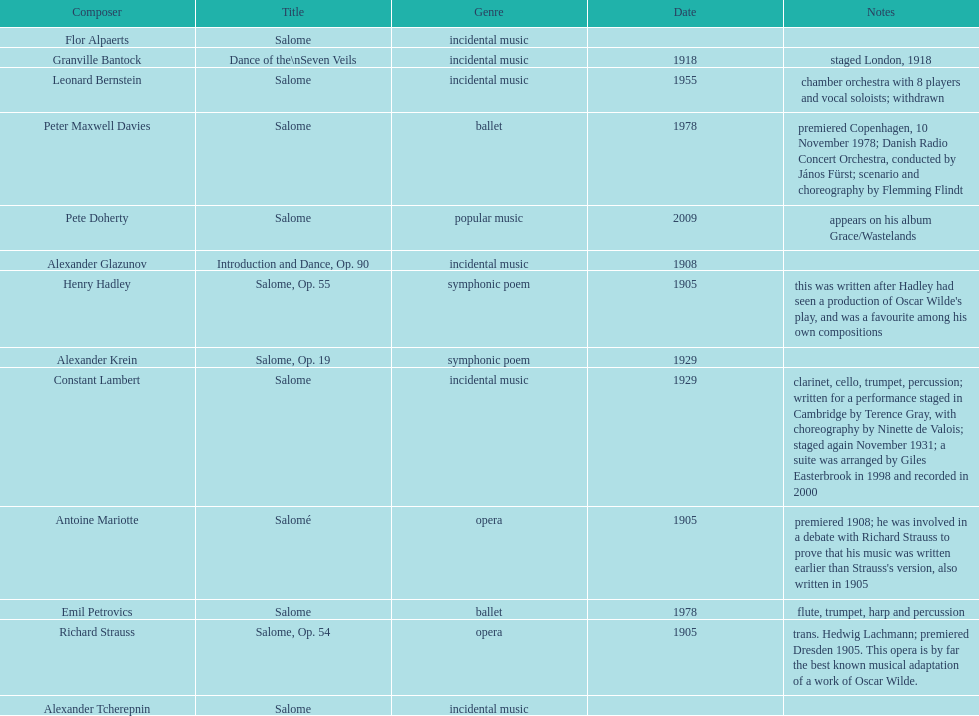What is the disparity in years between granville bantock's compositions and pete doherty's? 91. 